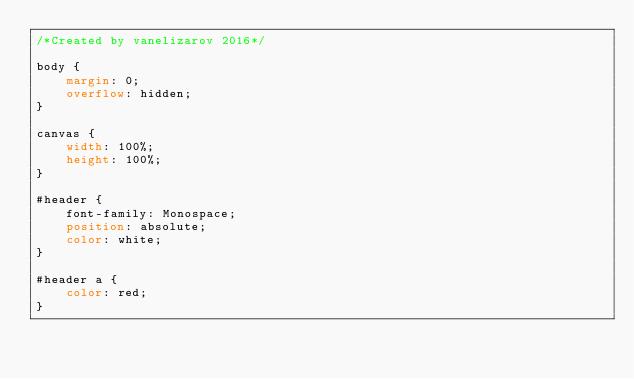<code> <loc_0><loc_0><loc_500><loc_500><_CSS_>/*Created by vanelizarov 2016*/

body {
    margin: 0;
    overflow: hidden;
}

canvas {
    width: 100%;
    height: 100%;
}

#header {
    font-family: Monospace;
    position: absolute;
    color: white;
}

#header a {
    color: red;
}
</code> 